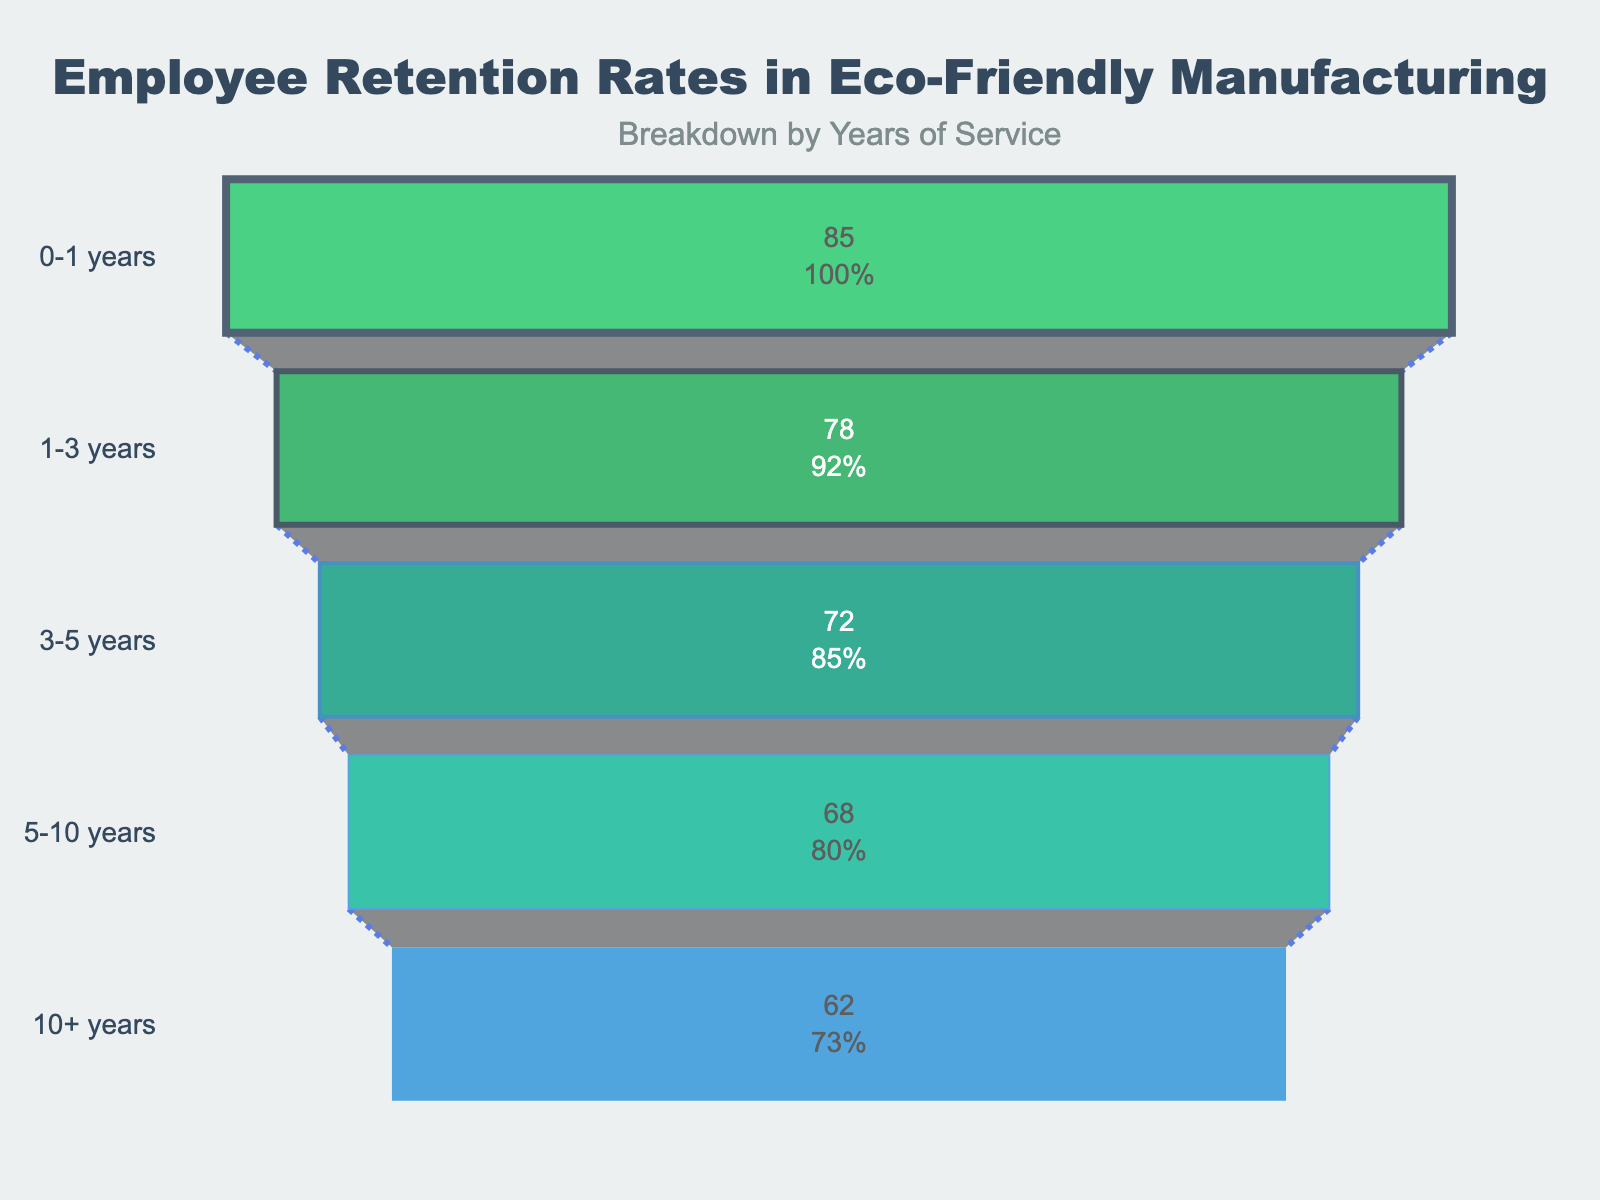What's the title of the chart? The title is located at the top center of the chart, formatted in larger and bold text. The title reads "Employee Retention Rates in Eco-Friendly Manufacturing".
Answer: Employee Retention Rates in Eco-Friendly Manufacturing What is the retention rate for employees with 3-5 years of service? Locate the section labeled "3-5 years" on the y-axis (left side of the chart). The retention rate is displayed as a percentage inside the corresponding funnel section.
Answer: 72% How does the retention rate change as the years of service increase? Start by observing the retention rate for the lowest range (0-1 years) and then compare it progressively for each increase in years of service. As the years of service increase from "0-1 years" to "10+ years", the retention rate decreases.
Answer: It decreases Which group has the highest retention rate? Compare the retention rates displayed inside each funnel section. The highest retention rate will be the largest percentage.
Answer: 0-1 years What is the difference in retention rates between employees with 1-3 years and those with 5-10 years of service? First, find the retention rate for both groups (1-3 years = 78%, 5-10 years = 68%). Subtract the retention rate of the 5-10 years group from the 1-3 years group (78% - 68%).
Answer: 10% How many different year groups are represented in the chart? Count the distinct segments or labels on the y-axis. Each label represents a different year group.
Answer: 5 What percentage of employees with 10+ years stay with the company? Locate the section labeled "10+ years" on the y-axis. The retention rate is displayed as a percentage inside this section.
Answer: 62% How does the retention rate for employees with 0-1 years of service compare to that of employees with 1-3 years of service? Observe the retention rates for both groups (0-1 years = 85%, 1-3 years = 78%) and compare these percentages. The rate for 0-1 years is higher than that for 1-3 years.
Answer: Higher Which two consecutive year groups have the smallest reduction in retention rates? Calculate the retention rate difference for each consecutive year group. Compare the differences and identify the smallest (0-1 years to 1-3 years = 7%, 1-3 years to 3-5 years = 6%, 3-5 years to 5-10 years = 4%, 5-10 years to 10+ years = 6%). The smallest reduction is between 3-5 years and 5-10 years.
Answer: 3-5 years and 5-10 years What is the average retention rate across all year groups? Find the retention rates for all year groups and calculate the average. (85% + 78% + 72% + 68% + 62%) / 5 = 73%.
Answer: 73% 